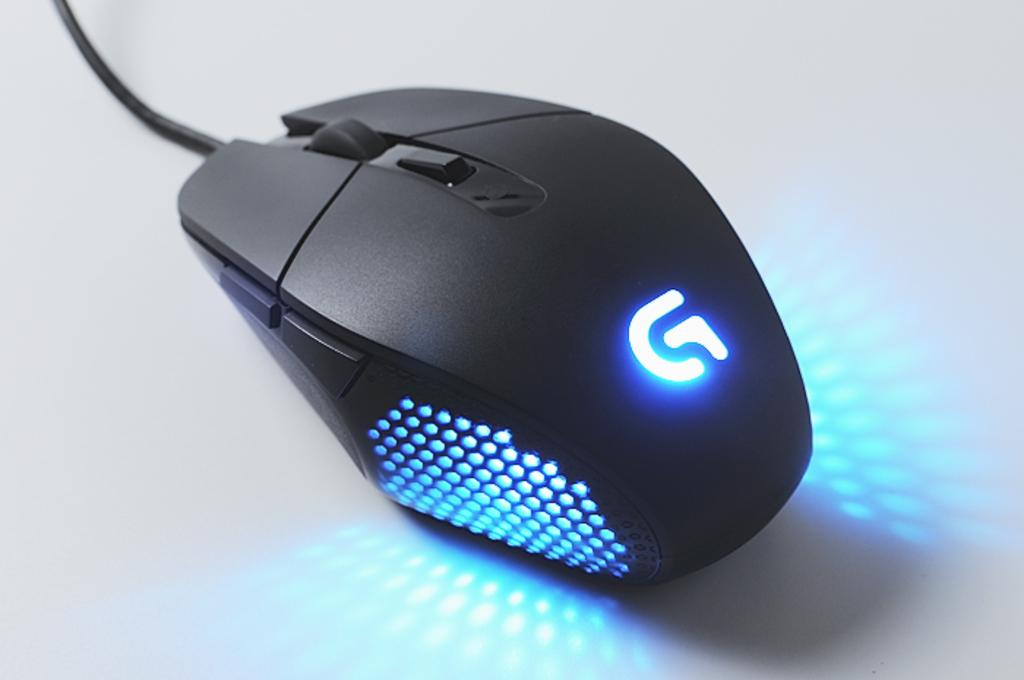<image>
Create a compact narrative representing the image presented. A very high tech mouse has the letter G lit up with glue lights. 